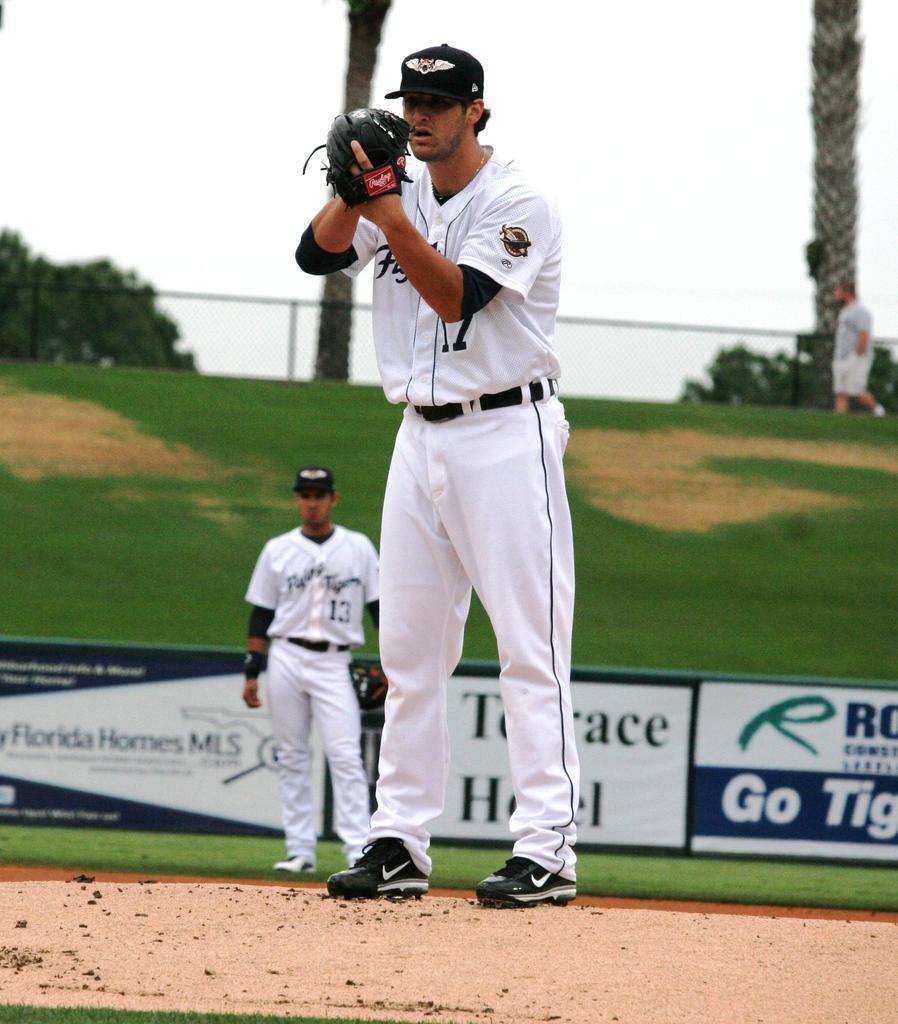Describe this image in one or two sentences. In the image I can see two people wearing white dress and standing on the floor and behind there is a fencing and some trees. 